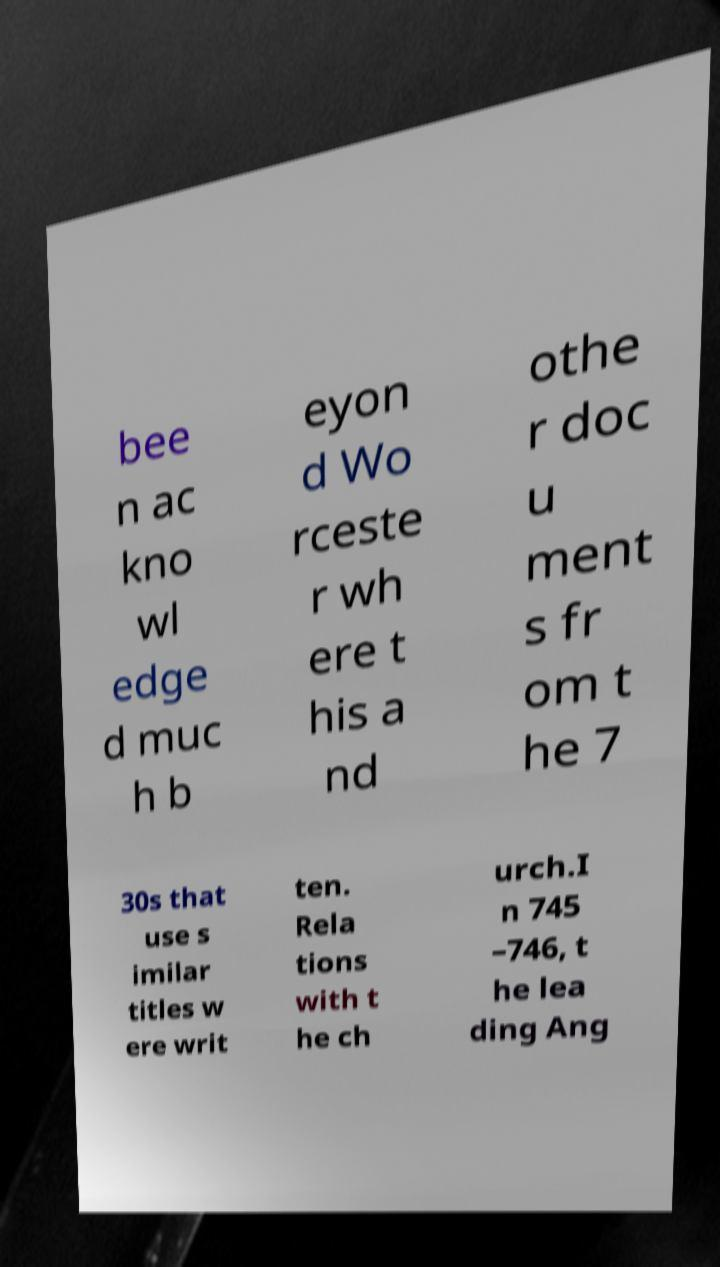Could you extract and type out the text from this image? bee n ac kno wl edge d muc h b eyon d Wo rceste r wh ere t his a nd othe r doc u ment s fr om t he 7 30s that use s imilar titles w ere writ ten. Rela tions with t he ch urch.I n 745 –746, t he lea ding Ang 